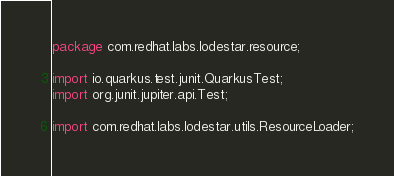Convert code to text. <code><loc_0><loc_0><loc_500><loc_500><_Java_>package com.redhat.labs.lodestar.resource;

import io.quarkus.test.junit.QuarkusTest;
import org.junit.jupiter.api.Test;

import com.redhat.labs.lodestar.utils.ResourceLoader;
</code> 